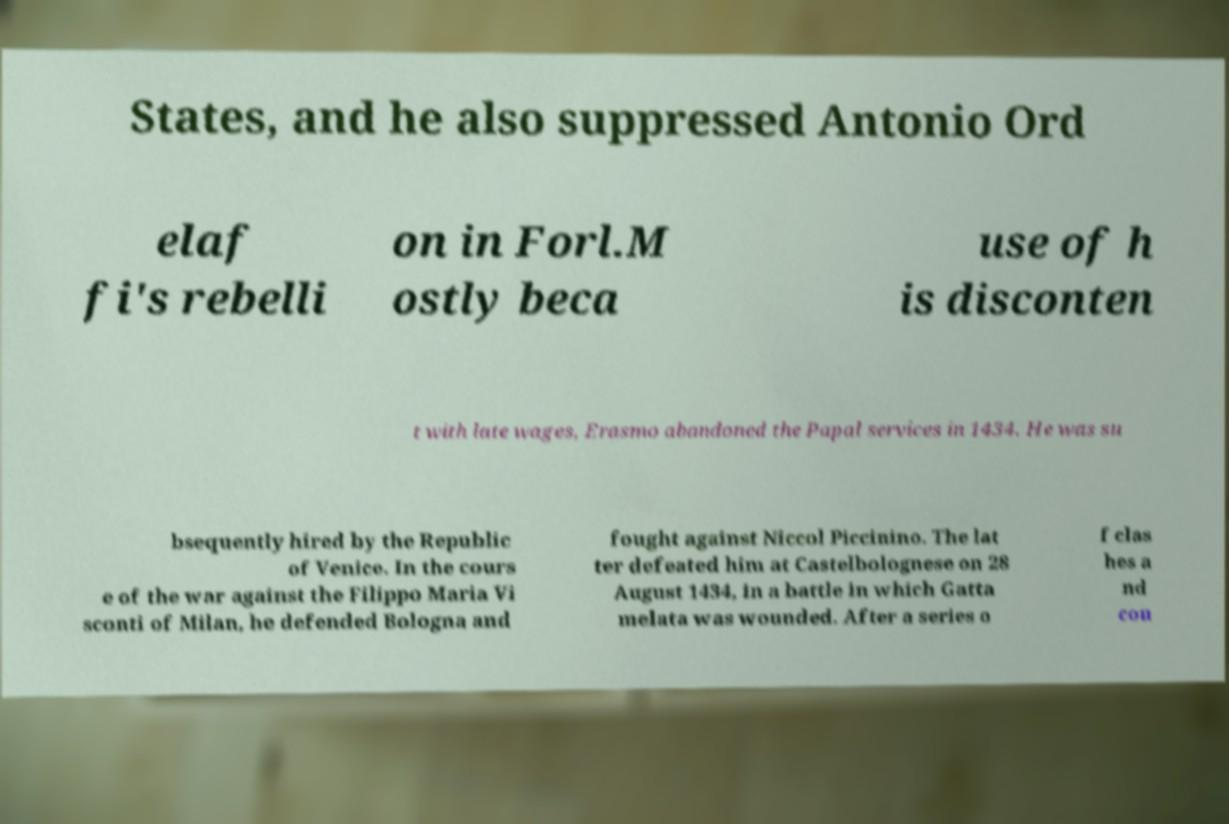Please identify and transcribe the text found in this image. States, and he also suppressed Antonio Ord elaf fi's rebelli on in Forl.M ostly beca use of h is disconten t with late wages, Erasmo abandoned the Papal services in 1434. He was su bsequently hired by the Republic of Venice. In the cours e of the war against the Filippo Maria Vi sconti of Milan, he defended Bologna and fought against Niccol Piccinino. The lat ter defeated him at Castelbolognese on 28 August 1434, in a battle in which Gatta melata was wounded. After a series o f clas hes a nd cou 